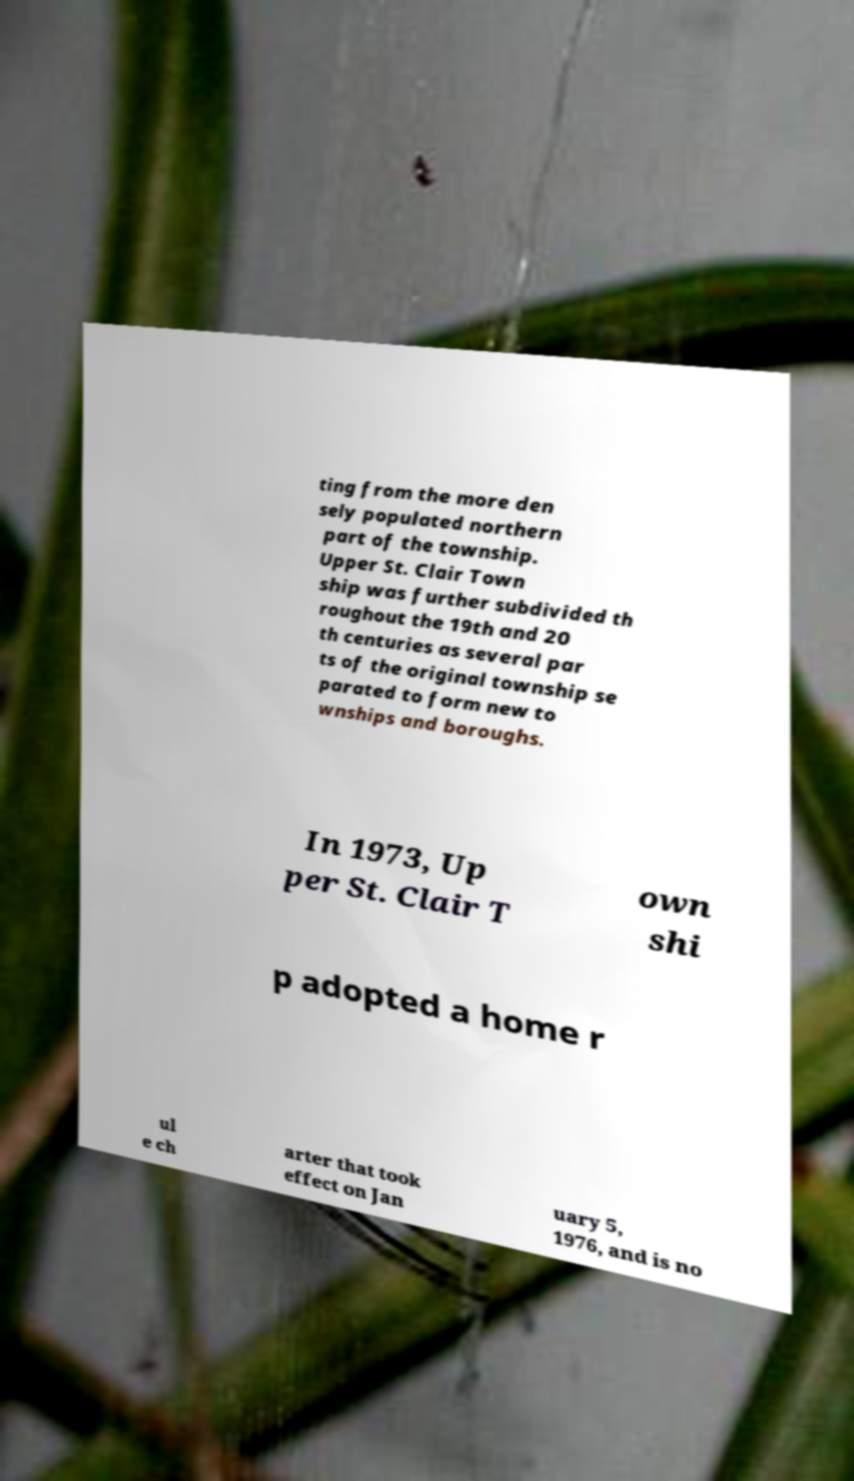Can you accurately transcribe the text from the provided image for me? ting from the more den sely populated northern part of the township. Upper St. Clair Town ship was further subdivided th roughout the 19th and 20 th centuries as several par ts of the original township se parated to form new to wnships and boroughs. In 1973, Up per St. Clair T own shi p adopted a home r ul e ch arter that took effect on Jan uary 5, 1976, and is no 